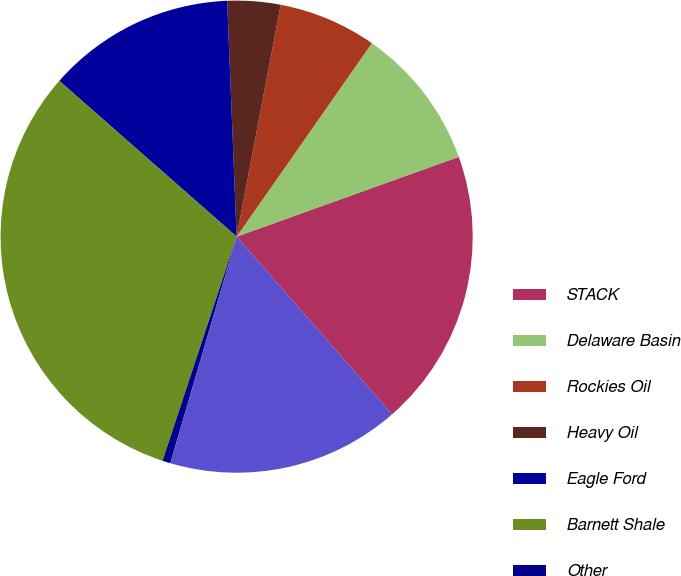<chart> <loc_0><loc_0><loc_500><loc_500><pie_chart><fcel>STACK<fcel>Delaware Basin<fcel>Rockies Oil<fcel>Heavy Oil<fcel>Eagle Ford<fcel>Barnett Shale<fcel>Other<fcel>Divested assets<nl><fcel>19.05%<fcel>9.8%<fcel>6.72%<fcel>3.63%<fcel>12.89%<fcel>31.39%<fcel>0.55%<fcel>15.97%<nl></chart> 